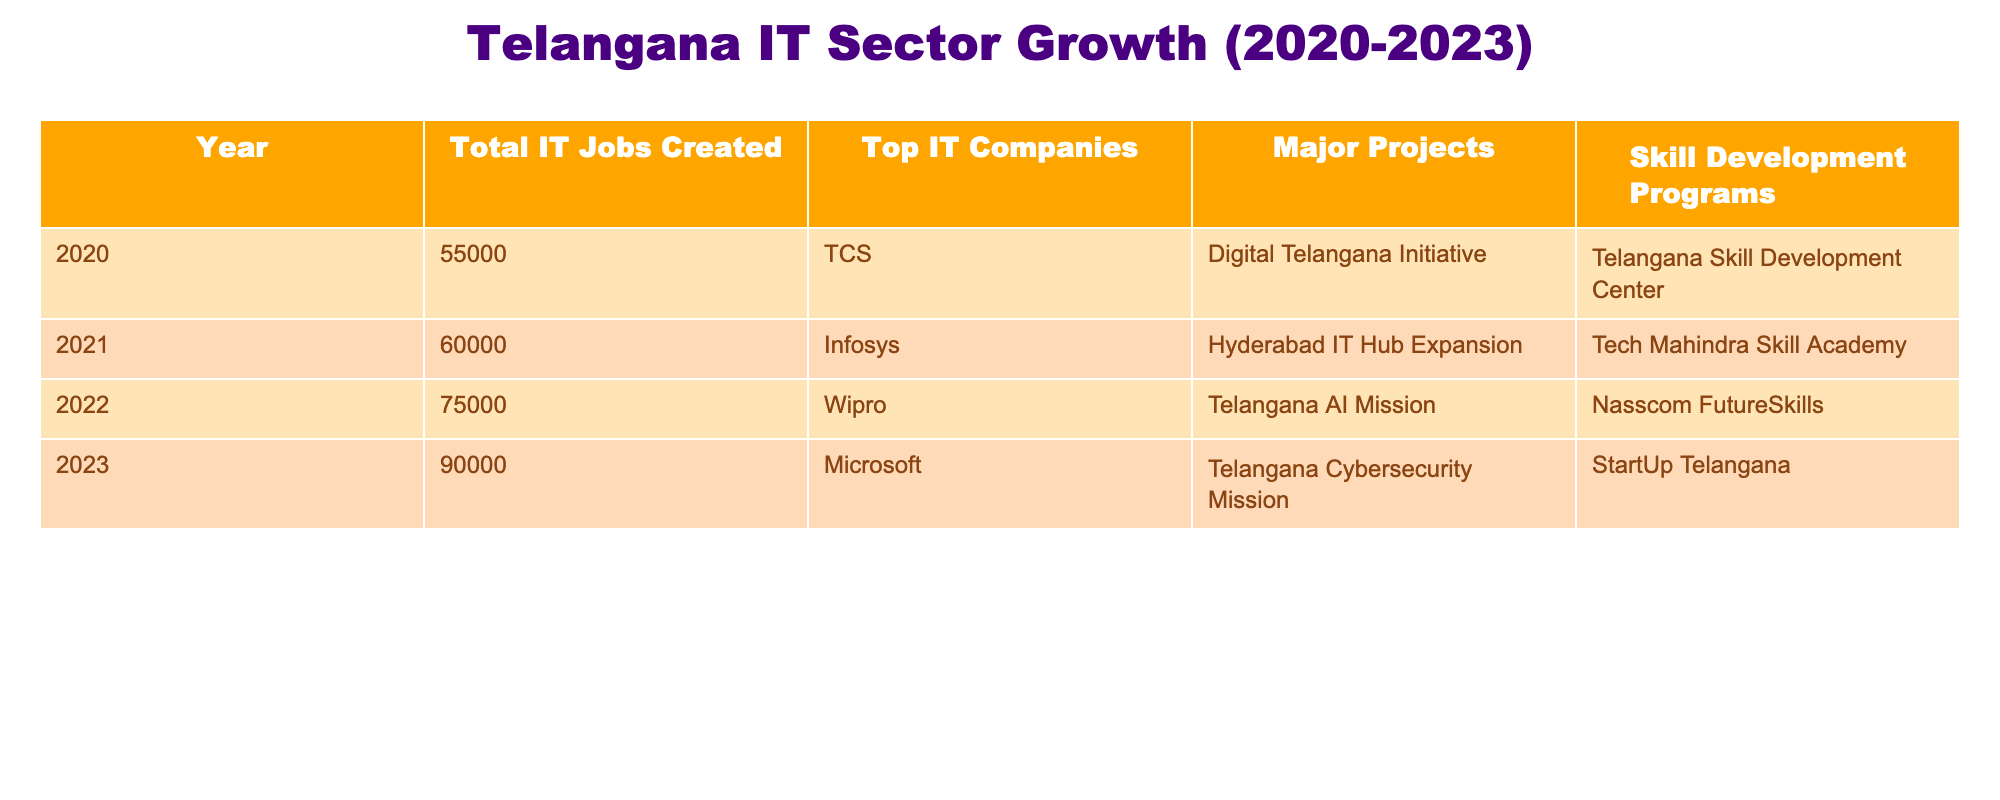What was the total number of IT jobs created in Telangana in 2021? From the table, under the column "Total IT Jobs Created," the row for the year 2021 shows the value 60000.
Answer: 60000 Which year saw the highest number of IT jobs created? By comparing the total jobs created from each year, 2023 has the highest value at 90000, while 2022 follows with 75000.
Answer: 2023 What is the average number of IT jobs created from 2020 to 2023? To find the average, sum the total jobs: (55000 + 60000 + 75000 + 90000) = 280000. Then divide by the number of years: 280000 / 4 = 70000.
Answer: 70000 Did Wipro implement any major projects in Telangana in 2022? According to the table, the entry for Wipro in 2022 lists "Telangana AI Mission" as a major project, which confirms that Wipro was involved in major projects that year.
Answer: Yes How many more jobs were created from 2020 to 2023 compared to the previous three years (2020-2022)? The total number of jobs created from 2020 to 2023 is 90000 in 2023; from 2020 to 2022, it's 75000. The difference in jobs created is 90000 - 75000 = 15000.
Answer: 15000 What is the total number of skill development programs noted from 2020 to 2023? The programs listed are as follows - 2020 (1), 2021 (1), 2022 (1), and 2023 (1), totaling 4 skill development programs over these years.
Answer: 4 Which companies were involved in the IT sector growth in 2022? Referring to the 'Top IT Companies' column, the entry for 2022 shows Wipro.
Answer: Wipro Was there an increase in the number of IT jobs created each year from 2020 to 2023? Each year's total IT jobs created is listed in ascending order: 55000 (2020), 60000 (2021), 75000 (2022), and 90000 (2023), showing a consistent increase each year.
Answer: Yes 